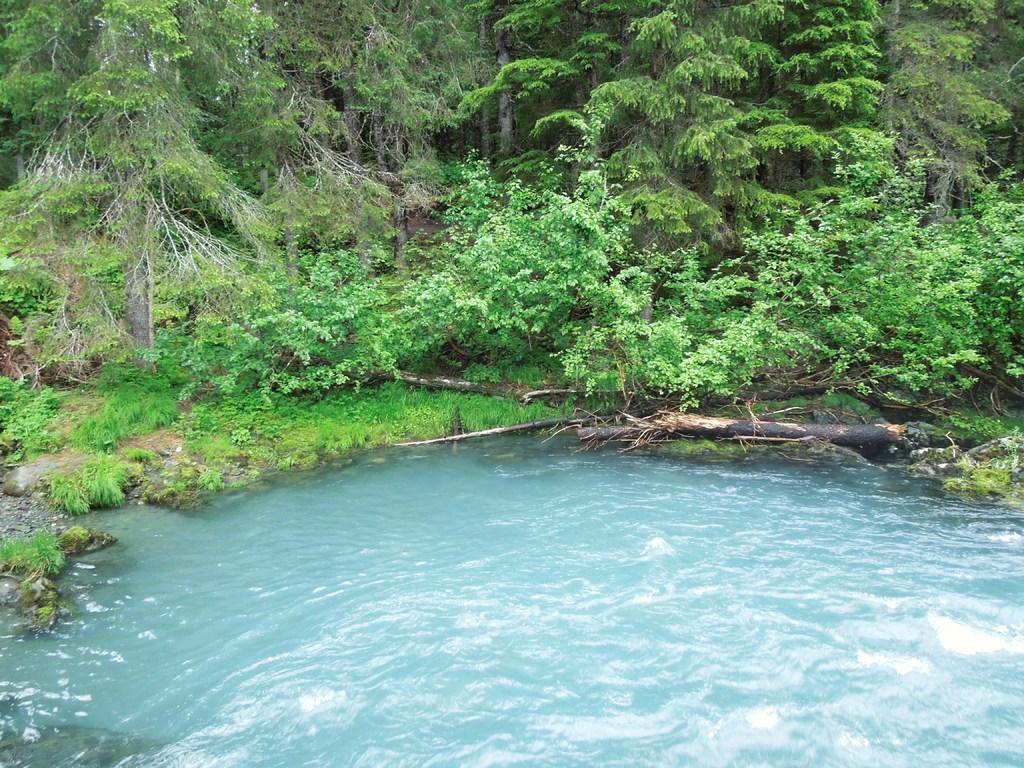Describe this image in one or two sentences. In this image there is water. Beside there is land having few plants, trees and few wooden trunks on it. 